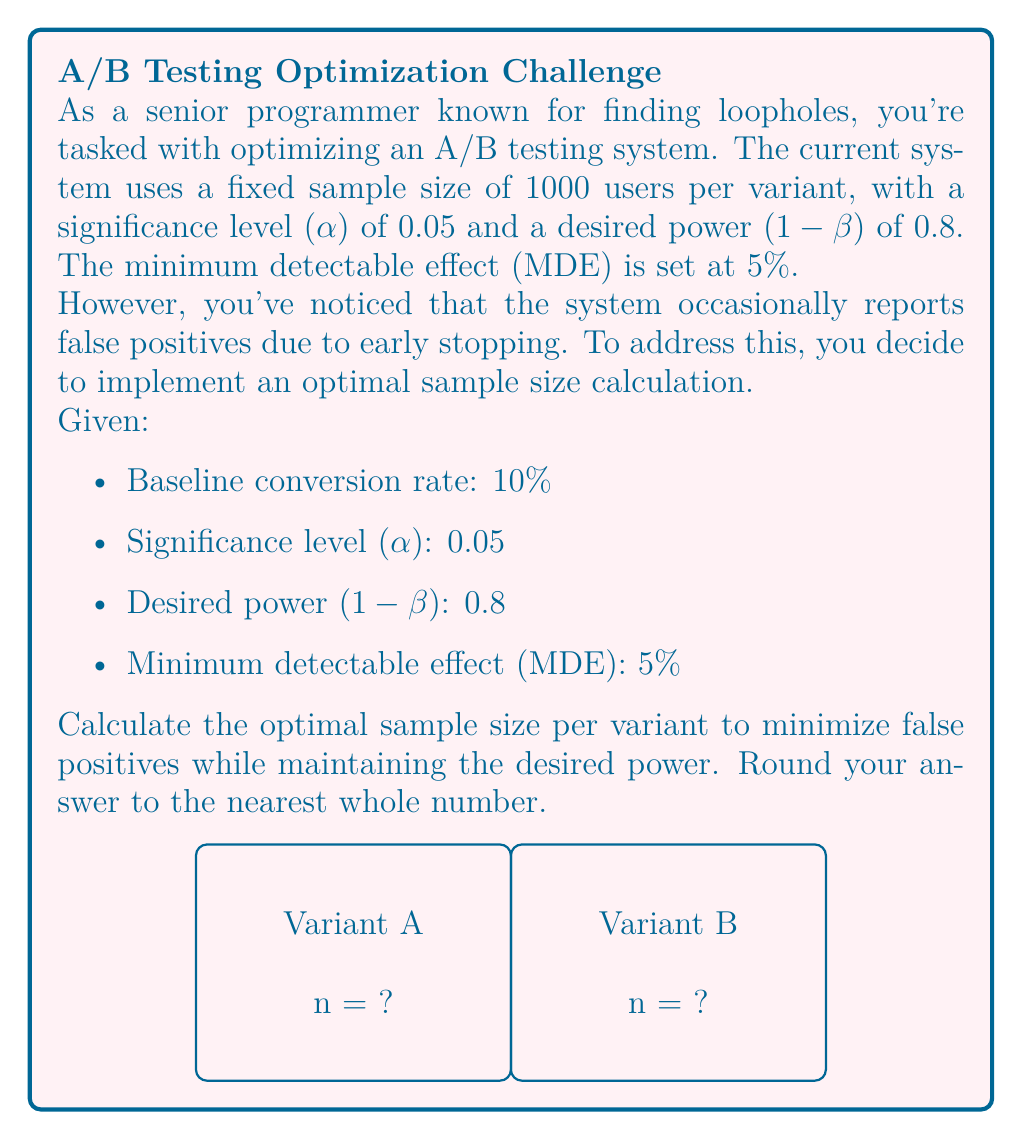Can you answer this question? To calculate the optimal sample size for A/B testing, we'll use the following formula:

$$ n = \frac{2(Z_{\alpha/2} + Z_{\beta})^2 \cdot p(1-p)}{(p_1 - p_2)^2} $$

Where:
- $n$ is the sample size per variant
- $Z_{\alpha/2}$ is the Z-score for the significance level (α/2)
- $Z_{\beta}$ is the Z-score for the desired power (1-β)
- $p$ is the baseline conversion rate
- $p_1 - p_2$ is the minimum detectable effect (MDE)

Step 1: Determine Z-scores
- For α = 0.05, $Z_{\alpha/2} = 1.96$
- For 1-β = 0.8, $Z_{\beta} = 0.84$

Step 2: Calculate $p_1 - p_2$
$p_1 - p_2 = 0.05$ (given MDE)

Step 3: Substitute values into the formula
$$ n = \frac{2(1.96 + 0.84)^2 \cdot 0.1(1-0.1)}{0.05^2} $$

Step 4: Simplify and calculate
$$ n = \frac{2(2.8)^2 \cdot 0.1 \cdot 0.9}{0.0025} $$
$$ n = \frac{1.4112 \cdot 0.09}{0.0025} $$
$$ n = 507.8304 $$

Step 5: Round to the nearest whole number
$n ≈ 508$

Therefore, the optimal sample size per variant is 508 users.
Answer: 508 users per variant 